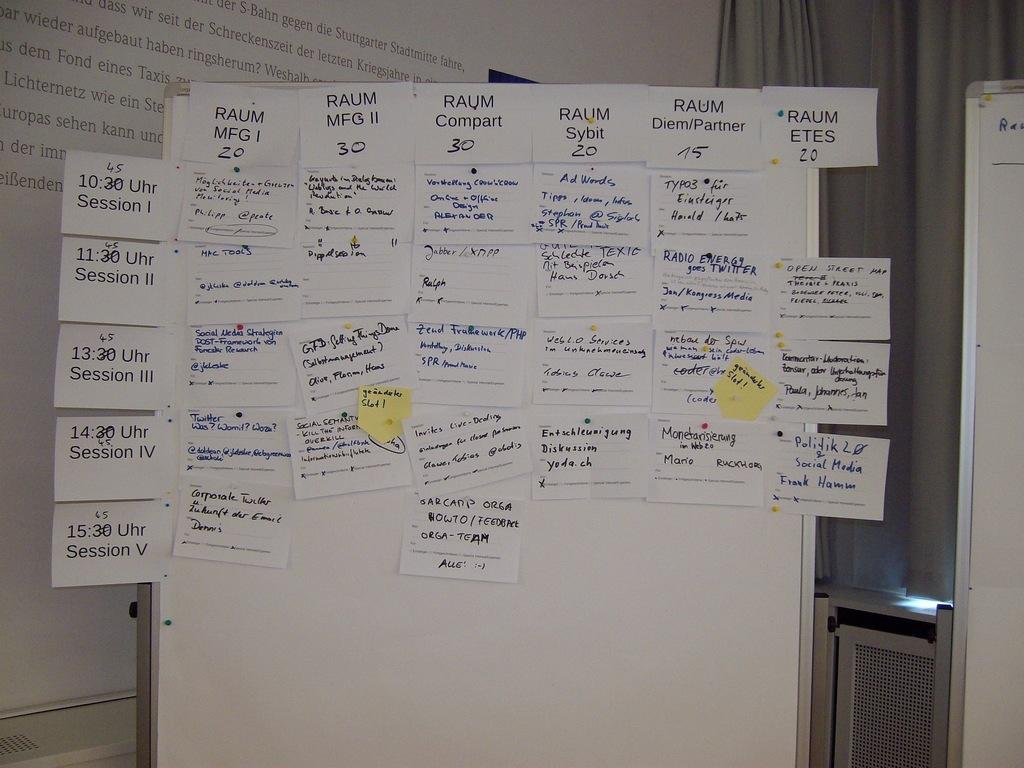<image>
Write a terse but informative summary of the picture. Session one of the event is at 10:45 